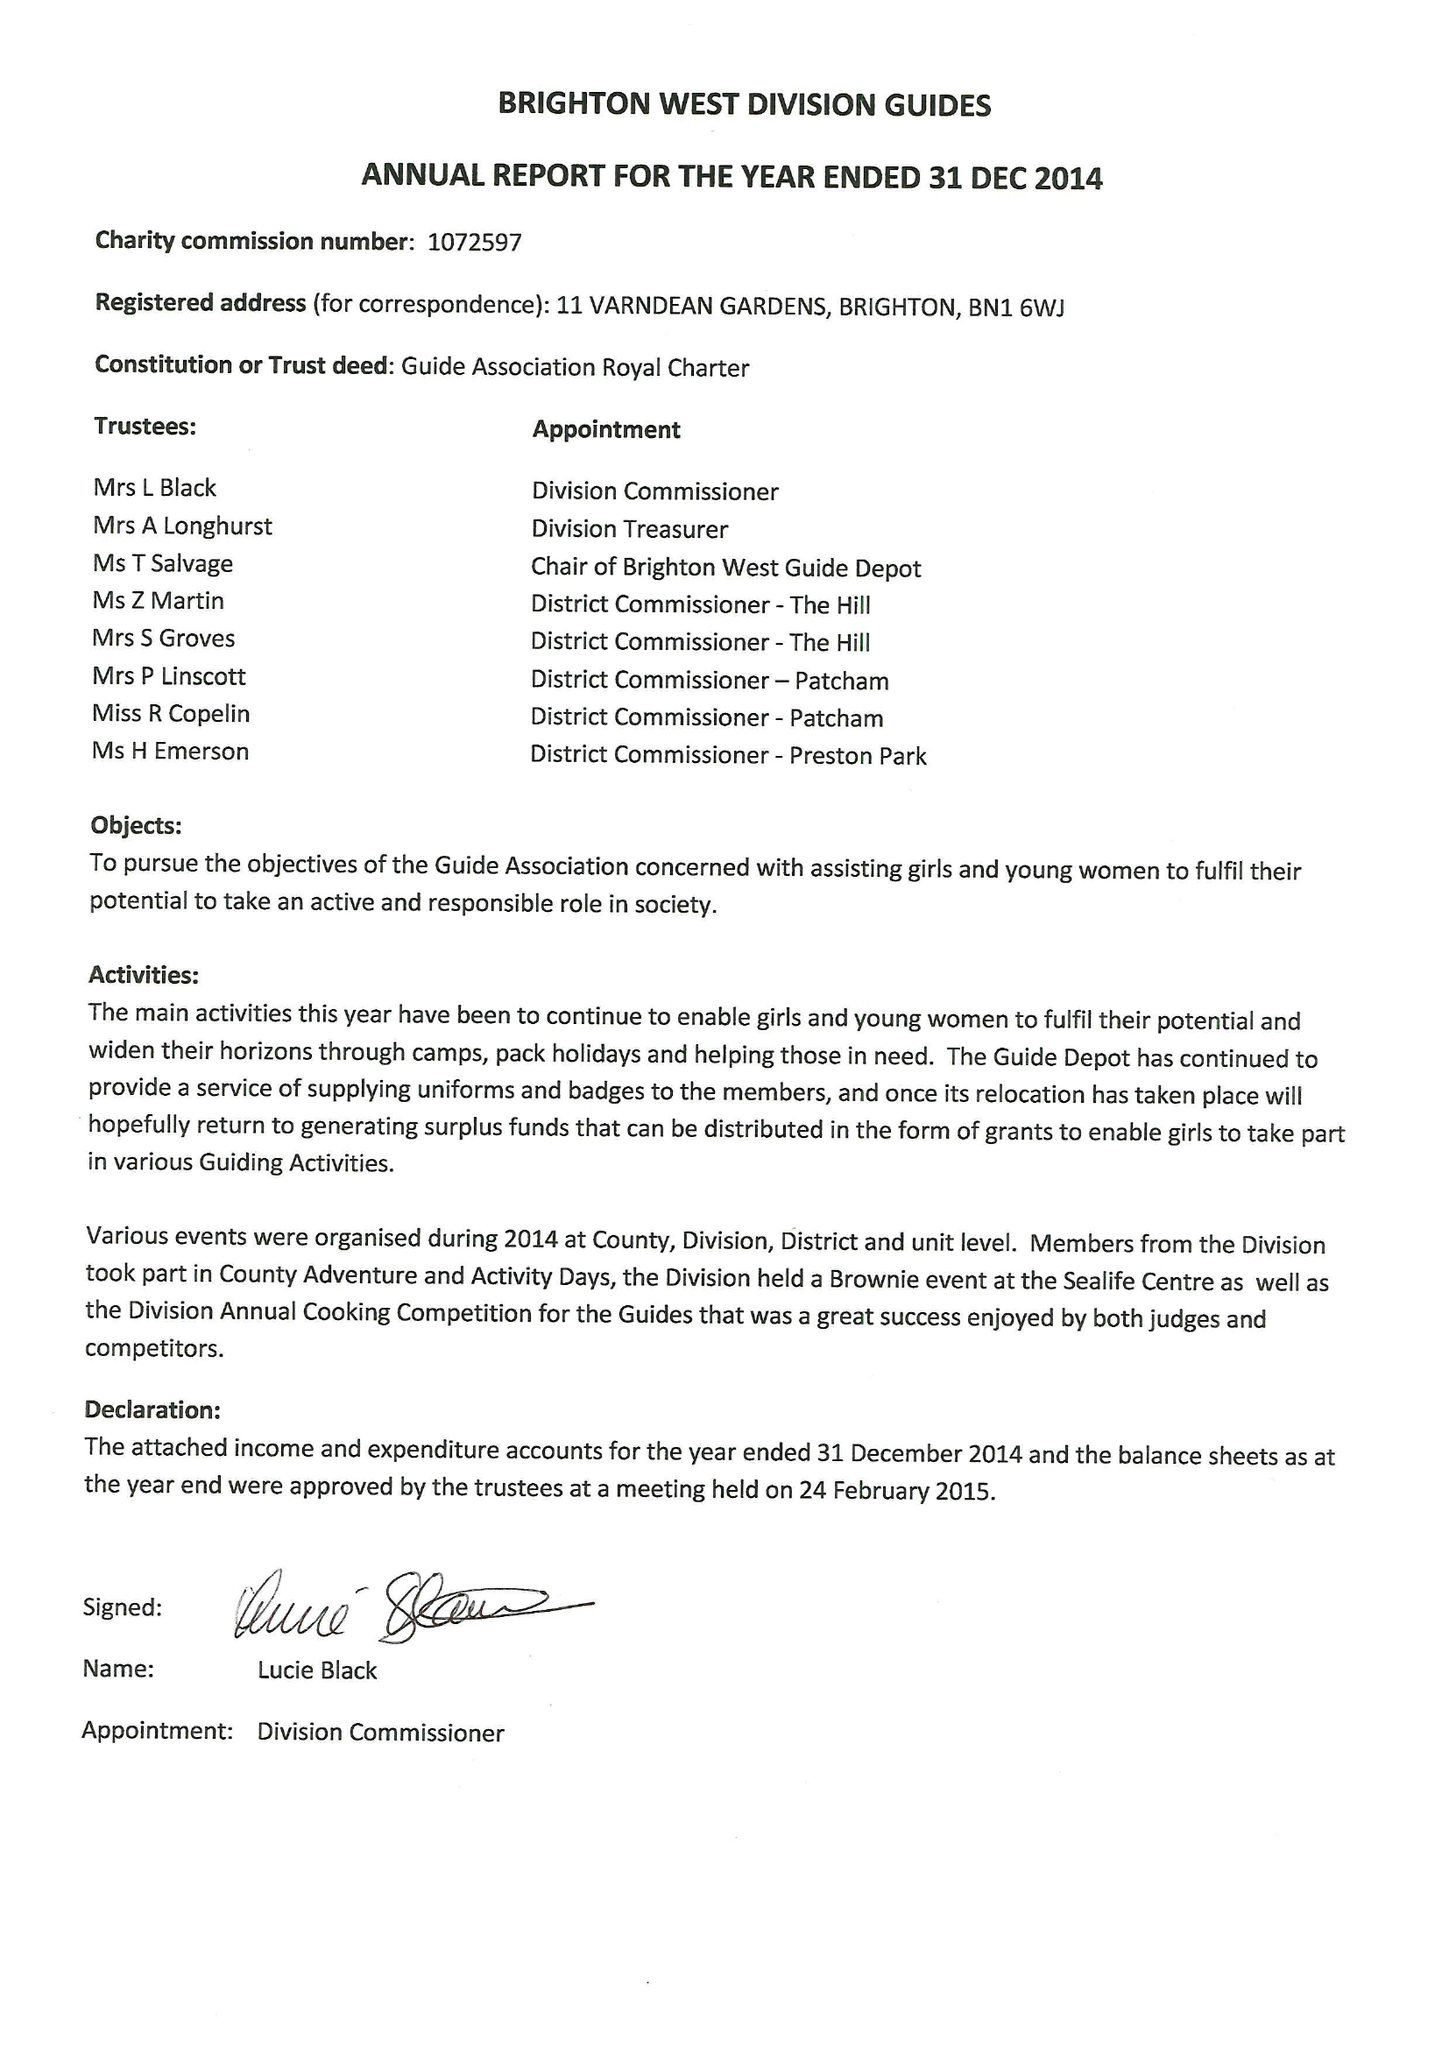What is the value for the address__post_town?
Answer the question using a single word or phrase. BRIGHTON 